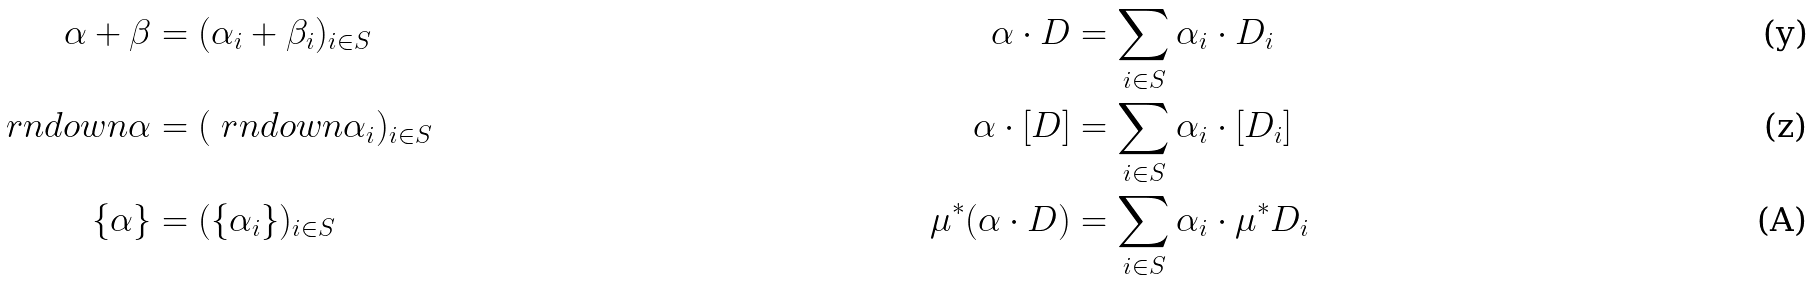<formula> <loc_0><loc_0><loc_500><loc_500>\alpha + \beta & = ( \alpha _ { i } + \beta _ { i } ) _ { i \in S } & \alpha \cdot D & = \sum _ { i \in S } \alpha _ { i } \cdot D _ { i } \\ \ r n d o w n { \alpha } & = ( \ r n d o w n { \alpha _ { i } } ) _ { i \in S } & \alpha \cdot [ D ] & = \sum _ { i \in S } \alpha _ { i } \cdot [ D _ { i } ] \\ \{ \alpha \} & = ( \{ \alpha _ { i } \} ) _ { i \in S } & \mu ^ { * } ( \alpha \cdot D ) & = \sum _ { i \in S } \alpha _ { i } \cdot \mu ^ { * } D _ { i }</formula> 